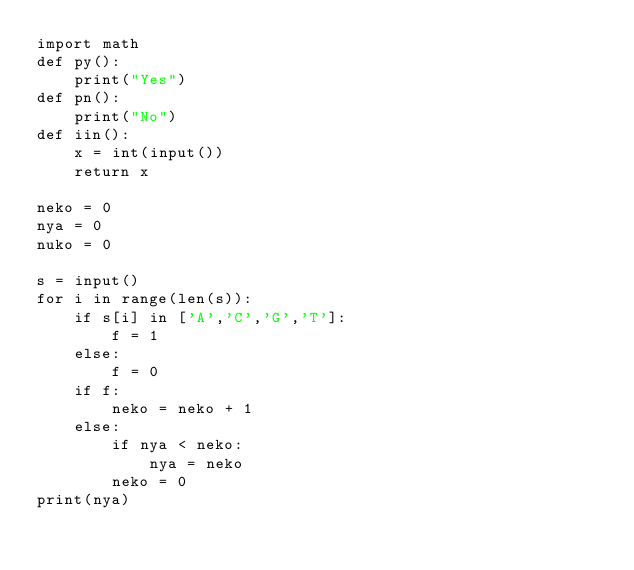<code> <loc_0><loc_0><loc_500><loc_500><_Python_>import math
def py():
    print("Yes")
def pn():
    print("No")
def iin():
    x = int(input())
    return x

neko = 0
nya = 0
nuko = 0

s = input()
for i in range(len(s)):
    if s[i] in ['A','C','G','T']:
        f = 1
    else:
        f = 0
    if f:
        neko = neko + 1
    else:
        if nya < neko:
            nya = neko
        neko = 0
print(nya)</code> 